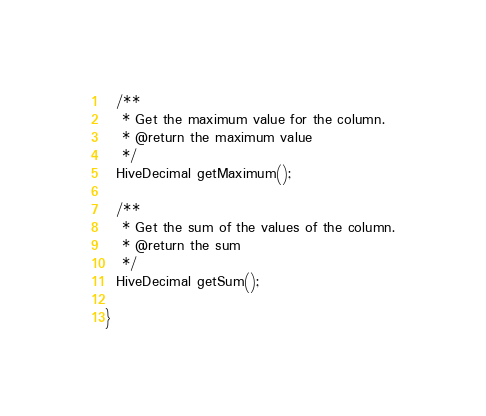<code> <loc_0><loc_0><loc_500><loc_500><_Java_>  /**
   * Get the maximum value for the column.
   * @return the maximum value
   */
  HiveDecimal getMaximum();

  /**
   * Get the sum of the values of the column.
   * @return the sum
   */
  HiveDecimal getSum();

}
</code> 